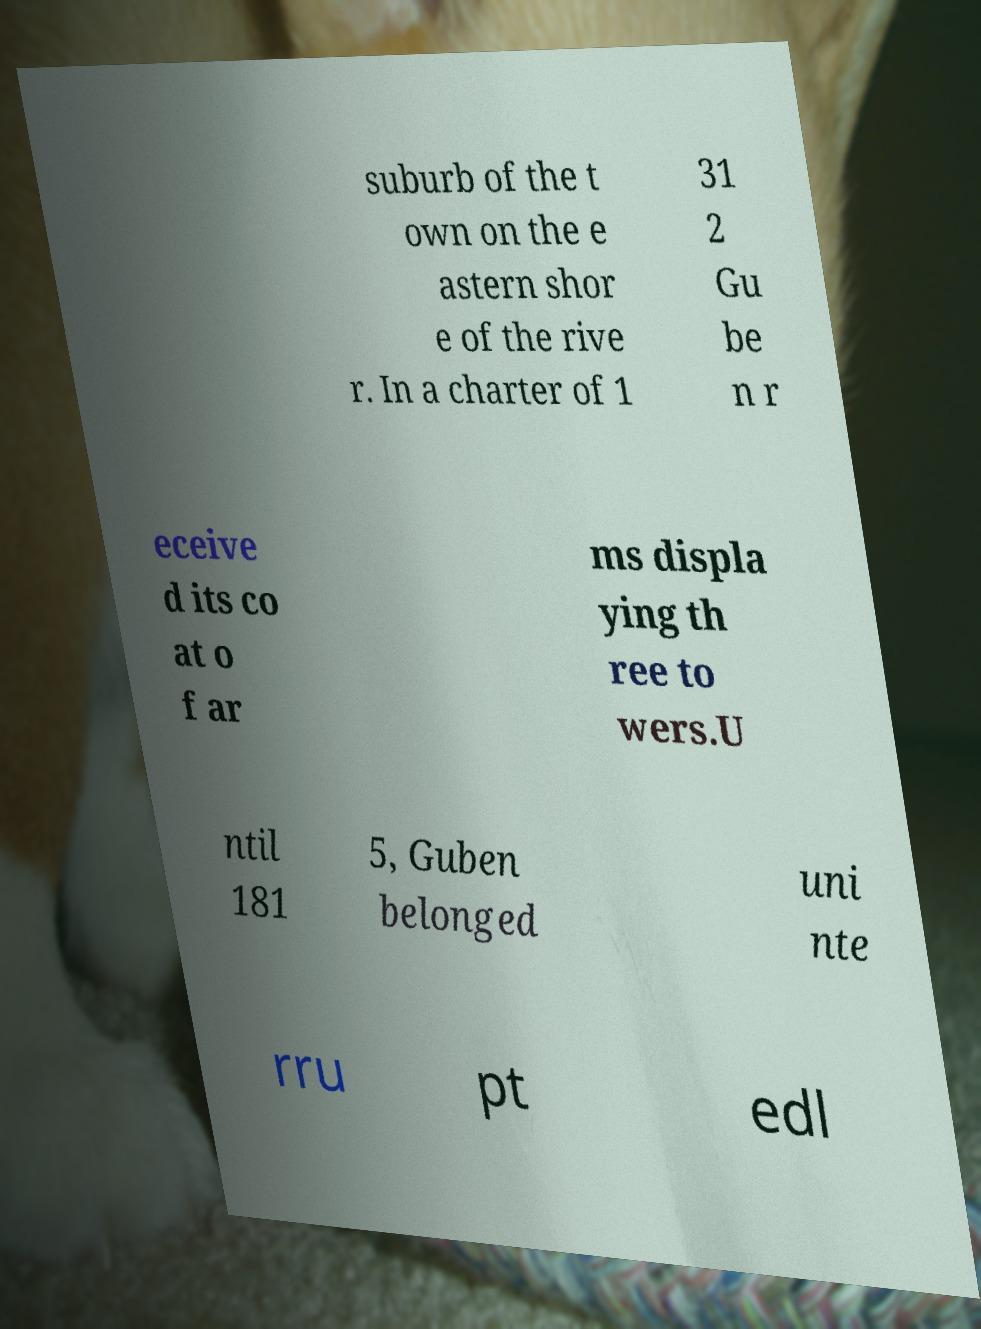Could you extract and type out the text from this image? suburb of the t own on the e astern shor e of the rive r. In a charter of 1 31 2 Gu be n r eceive d its co at o f ar ms displa ying th ree to wers.U ntil 181 5, Guben belonged uni nte rru pt edl 